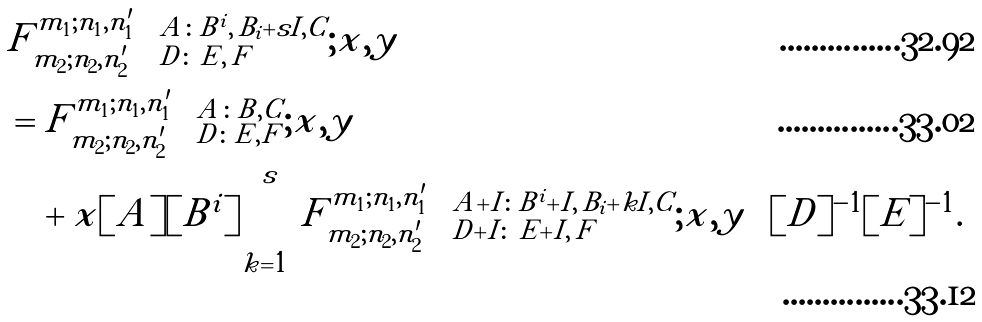Convert formula to latex. <formula><loc_0><loc_0><loc_500><loc_500>& F ^ { m _ { 1 } ; n _ { 1 } , n ^ { \prime } _ { 1 } } _ { m _ { 2 } ; n _ { 2 } , n ^ { \prime } _ { 2 } } \left ( ^ { A \colon B ^ { i } , \, B _ { i } + s I , C } _ { D \colon \, E , \, F } ; x , y \right ) \\ & = F ^ { m _ { 1 } ; n _ { 1 } , n ^ { \prime } _ { 1 } } _ { m _ { 2 } ; n _ { 2 } , n ^ { \prime } _ { 2 } } \left ( ^ { A \colon B , C } _ { D \colon E , F } ; x , y \right ) \\ & \quad + x [ A ] [ B ^ { i } ] \sum _ { k = 1 } ^ { s } F ^ { m _ { 1 } ; n _ { 1 } , n ^ { \prime } _ { 1 } } _ { m _ { 2 } ; n _ { 2 } , n ^ { \prime } _ { 2 } } \left ( ^ { A + I \colon B ^ { i } + I , \, B _ { i } + k I , C } _ { D + I \colon \, E + I , \, F } ; x , y \right ) [ D ] ^ { - 1 } [ E ] ^ { - 1 } .</formula> 